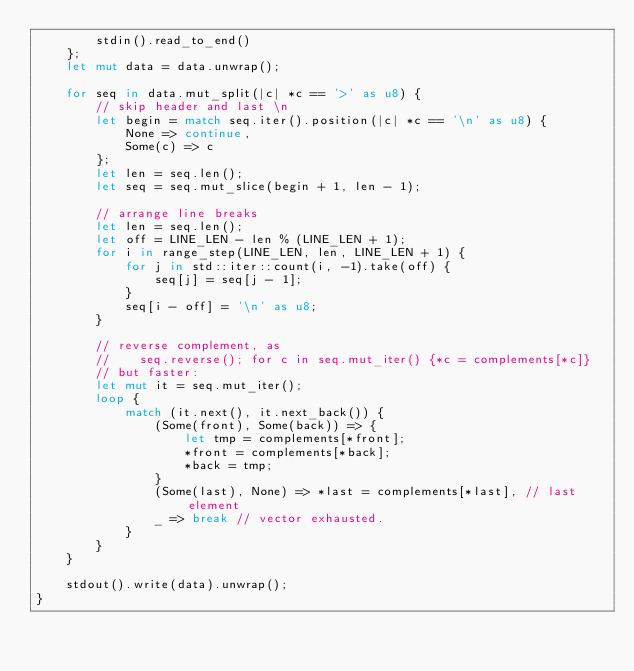<code> <loc_0><loc_0><loc_500><loc_500><_Rust_>        stdin().read_to_end()
    };
    let mut data = data.unwrap();

    for seq in data.mut_split(|c| *c == '>' as u8) {
        // skip header and last \n
        let begin = match seq.iter().position(|c| *c == '\n' as u8) {
            None => continue,
            Some(c) => c
        };
        let len = seq.len();
        let seq = seq.mut_slice(begin + 1, len - 1);

        // arrange line breaks
        let len = seq.len();
        let off = LINE_LEN - len % (LINE_LEN + 1);
        for i in range_step(LINE_LEN, len, LINE_LEN + 1) {
            for j in std::iter::count(i, -1).take(off) {
                seq[j] = seq[j - 1];
            }
            seq[i - off] = '\n' as u8;
        }

        // reverse complement, as
        //    seq.reverse(); for c in seq.mut_iter() {*c = complements[*c]}
        // but faster:
        let mut it = seq.mut_iter();
        loop {
            match (it.next(), it.next_back()) {
                (Some(front), Some(back)) => {
                    let tmp = complements[*front];
                    *front = complements[*back];
                    *back = tmp;
                }
                (Some(last), None) => *last = complements[*last], // last element
                _ => break // vector exhausted.
            }
        }
    }

    stdout().write(data).unwrap();
}
</code> 